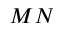Convert formula to latex. <formula><loc_0><loc_0><loc_500><loc_500>M N</formula> 